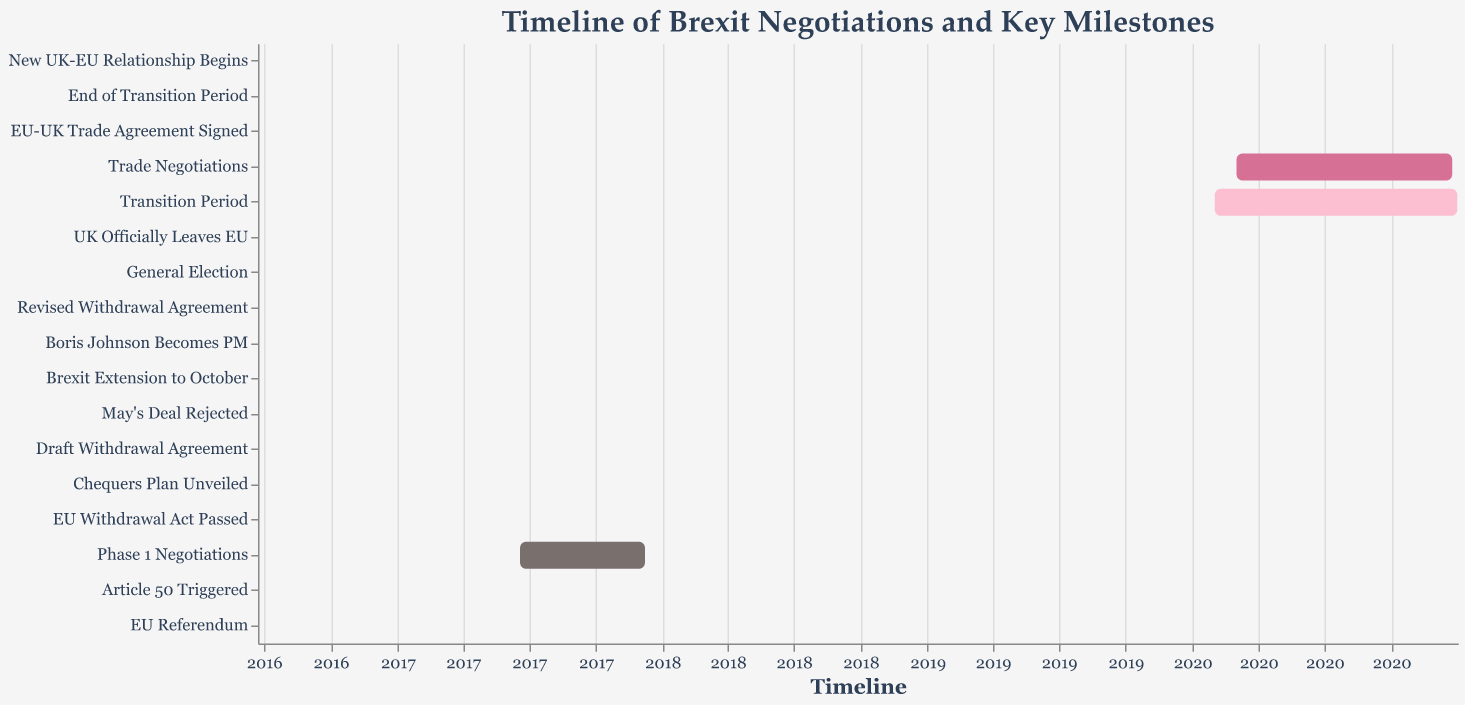What is the title of the figure? The title appears at the top of the figure, indicating the subject of the visualization. The text is "Timeline of Brexit Negotiations and Key Milestones."
Answer: Timeline of Brexit Negotiations and Key Milestones When did the UK officially leave the EU? Locate the "UK Officially Leaves EU" bar on the timeline. The start and end date show this event occurred on 2020-01-31.
Answer: 2020-01-31 What is the duration of the Transition Period? Look at the "Transition Period" bar. The start date is 2020-02-01, and the end date is 2020-12-31. Subtract the start date from the end date to calculate the duration.
Answer: 11 months Which event happened immediately after "May's Deal Rejected"? Follow the sequence of bars on the figure to find the one that comes immediately after "May's Deal Rejected," which is "Brexit Extension to October" next on the timeline.
Answer: Brexit Extension to October What date marks the start of the new UK-EU relationship? Identify the "New UK-EU Relationship Begins" bar and refer to its labeled start date.
Answer: 2021-01-01 How long did the Trade Negotiations last? Identify the "Trade Negotiations" bar. It began on 2020-03-02 and ended on 2020-12-24. Subtract the start date from the end date to find the duration.
Answer: Approximately 9 months and 22 days Compare the duration of Phase 1 Negotiations with Trade Negotiations. Which was longer? Check the duration of both "Phase 1 Negotiations" and "Trade Negotiations." Phase 1 lasted from 2017-06-19 to 2017-12-08, and Trade Negotiations lasted from 2020-03-02 to 2020-12-24. Calculating both durations, "Trade Negotiations" was longer.
Answer: Trade Negotiations was longer Which event triggered the Second Brexit Extension? Check the timeline sequence for the event marked as "Brexit Extension to October." It follows "May's Deal Rejected," so the second extension happened after May's deal was rejected.
Answer: May's Deal Rejected What is the longest singular event duration on the timeline? Observe the lengths of the singular event bars in the timeline. "Transition Period" bar is notably longest, lasting from 2020-02-01 to 2020-12-31, which is about 11 months.
Answer: Transition Period 